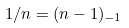Convert formula to latex. <formula><loc_0><loc_0><loc_500><loc_500>1 / n = ( n - 1 ) _ { - 1 }</formula> 